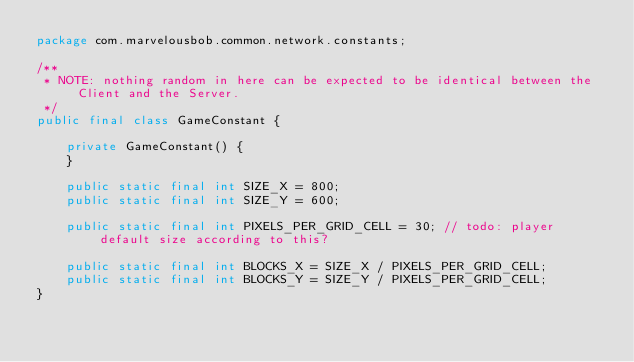Convert code to text. <code><loc_0><loc_0><loc_500><loc_500><_Java_>package com.marvelousbob.common.network.constants;

/**
 * NOTE: nothing random in here can be expected to be identical between the Client and the Server.
 */
public final class GameConstant {

    private GameConstant() {
    }

    public static final int SIZE_X = 800;
    public static final int SIZE_Y = 600;

    public static final int PIXELS_PER_GRID_CELL = 30; // todo: player default size according to this?

    public static final int BLOCKS_X = SIZE_X / PIXELS_PER_GRID_CELL;
    public static final int BLOCKS_Y = SIZE_Y / PIXELS_PER_GRID_CELL;
}
</code> 